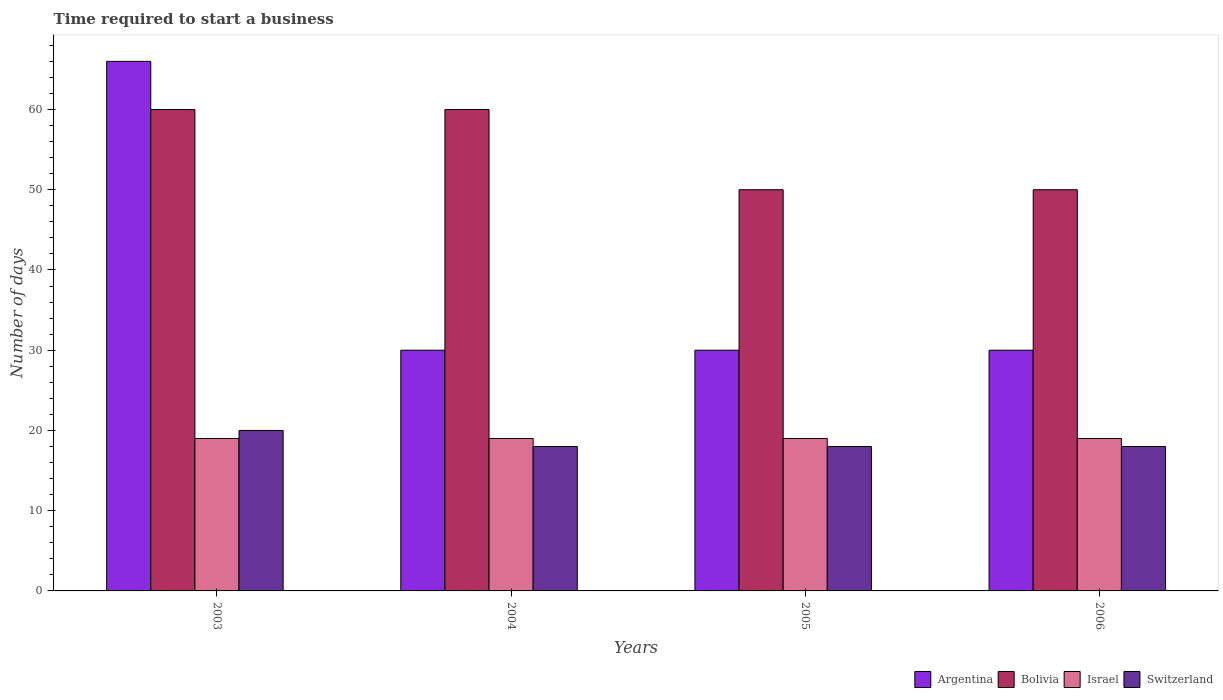How many groups of bars are there?
Offer a very short reply. 4. Are the number of bars per tick equal to the number of legend labels?
Make the answer very short. Yes. What is the label of the 3rd group of bars from the left?
Your answer should be very brief. 2005. Across all years, what is the maximum number of days required to start a business in Switzerland?
Keep it short and to the point. 20. Across all years, what is the minimum number of days required to start a business in Israel?
Your response must be concise. 19. What is the total number of days required to start a business in Argentina in the graph?
Provide a succinct answer. 156. What is the difference between the number of days required to start a business in Bolivia in 2003 and that in 2006?
Ensure brevity in your answer.  10. What is the difference between the number of days required to start a business in Argentina in 2005 and the number of days required to start a business in Israel in 2006?
Ensure brevity in your answer.  11. What is the average number of days required to start a business in Bolivia per year?
Provide a short and direct response. 55. In how many years, is the number of days required to start a business in Israel greater than 46 days?
Make the answer very short. 0. What is the ratio of the number of days required to start a business in Bolivia in 2003 to that in 2005?
Provide a succinct answer. 1.2. Is the difference between the number of days required to start a business in Bolivia in 2003 and 2004 greater than the difference between the number of days required to start a business in Argentina in 2003 and 2004?
Give a very brief answer. No. What is the difference between the highest and the lowest number of days required to start a business in Bolivia?
Your answer should be compact. 10. In how many years, is the number of days required to start a business in Bolivia greater than the average number of days required to start a business in Bolivia taken over all years?
Provide a short and direct response. 2. What does the 1st bar from the left in 2005 represents?
Your answer should be compact. Argentina. What does the 1st bar from the right in 2005 represents?
Offer a terse response. Switzerland. How many bars are there?
Keep it short and to the point. 16. What is the difference between two consecutive major ticks on the Y-axis?
Offer a very short reply. 10. Does the graph contain grids?
Your response must be concise. No. Where does the legend appear in the graph?
Ensure brevity in your answer.  Bottom right. How are the legend labels stacked?
Provide a succinct answer. Horizontal. What is the title of the graph?
Provide a short and direct response. Time required to start a business. What is the label or title of the X-axis?
Your response must be concise. Years. What is the label or title of the Y-axis?
Offer a very short reply. Number of days. What is the Number of days in Argentina in 2004?
Provide a short and direct response. 30. What is the Number of days of Bolivia in 2004?
Keep it short and to the point. 60. What is the Number of days of Israel in 2004?
Your response must be concise. 19. What is the Number of days in Switzerland in 2004?
Your answer should be compact. 18. What is the Number of days of Bolivia in 2005?
Give a very brief answer. 50. What is the Number of days of Switzerland in 2005?
Offer a very short reply. 18. What is the Number of days in Bolivia in 2006?
Offer a terse response. 50. What is the Number of days in Switzerland in 2006?
Offer a terse response. 18. Across all years, what is the maximum Number of days of Bolivia?
Provide a short and direct response. 60. Across all years, what is the maximum Number of days in Israel?
Give a very brief answer. 19. Across all years, what is the maximum Number of days of Switzerland?
Your answer should be very brief. 20. Across all years, what is the minimum Number of days in Bolivia?
Your answer should be very brief. 50. What is the total Number of days of Argentina in the graph?
Give a very brief answer. 156. What is the total Number of days of Bolivia in the graph?
Provide a short and direct response. 220. What is the total Number of days in Israel in the graph?
Your answer should be compact. 76. What is the difference between the Number of days of Argentina in 2003 and that in 2004?
Give a very brief answer. 36. What is the difference between the Number of days of Israel in 2003 and that in 2004?
Offer a terse response. 0. What is the difference between the Number of days in Argentina in 2003 and that in 2005?
Your response must be concise. 36. What is the difference between the Number of days of Bolivia in 2003 and that in 2006?
Provide a succinct answer. 10. What is the difference between the Number of days in Switzerland in 2003 and that in 2006?
Your answer should be very brief. 2. What is the difference between the Number of days in Argentina in 2004 and that in 2005?
Provide a succinct answer. 0. What is the difference between the Number of days in Bolivia in 2004 and that in 2005?
Provide a short and direct response. 10. What is the difference between the Number of days in Israel in 2004 and that in 2005?
Offer a terse response. 0. What is the difference between the Number of days of Switzerland in 2004 and that in 2005?
Make the answer very short. 0. What is the difference between the Number of days of Argentina in 2004 and that in 2006?
Your answer should be very brief. 0. What is the difference between the Number of days in Bolivia in 2004 and that in 2006?
Keep it short and to the point. 10. What is the difference between the Number of days in Argentina in 2005 and that in 2006?
Offer a very short reply. 0. What is the difference between the Number of days of Switzerland in 2005 and that in 2006?
Provide a succinct answer. 0. What is the difference between the Number of days of Bolivia in 2003 and the Number of days of Israel in 2004?
Give a very brief answer. 41. What is the difference between the Number of days of Bolivia in 2003 and the Number of days of Switzerland in 2004?
Make the answer very short. 42. What is the difference between the Number of days in Argentina in 2003 and the Number of days in Bolivia in 2005?
Your answer should be compact. 16. What is the difference between the Number of days in Argentina in 2003 and the Number of days in Switzerland in 2005?
Ensure brevity in your answer.  48. What is the difference between the Number of days in Bolivia in 2003 and the Number of days in Israel in 2005?
Keep it short and to the point. 41. What is the difference between the Number of days in Israel in 2003 and the Number of days in Switzerland in 2005?
Your answer should be compact. 1. What is the difference between the Number of days of Argentina in 2003 and the Number of days of Israel in 2006?
Keep it short and to the point. 47. What is the difference between the Number of days in Argentina in 2003 and the Number of days in Switzerland in 2006?
Make the answer very short. 48. What is the difference between the Number of days of Israel in 2003 and the Number of days of Switzerland in 2006?
Your answer should be compact. 1. What is the difference between the Number of days of Argentina in 2004 and the Number of days of Israel in 2005?
Provide a short and direct response. 11. What is the difference between the Number of days in Argentina in 2004 and the Number of days in Switzerland in 2005?
Your answer should be compact. 12. What is the difference between the Number of days of Bolivia in 2004 and the Number of days of Israel in 2005?
Provide a short and direct response. 41. What is the difference between the Number of days of Israel in 2004 and the Number of days of Switzerland in 2005?
Provide a short and direct response. 1. What is the difference between the Number of days of Argentina in 2004 and the Number of days of Israel in 2006?
Ensure brevity in your answer.  11. What is the difference between the Number of days in Argentina in 2004 and the Number of days in Switzerland in 2006?
Your answer should be compact. 12. What is the difference between the Number of days of Bolivia in 2004 and the Number of days of Israel in 2006?
Offer a terse response. 41. What is the difference between the Number of days in Argentina in 2005 and the Number of days in Switzerland in 2006?
Provide a short and direct response. 12. What is the difference between the Number of days in Bolivia in 2005 and the Number of days in Switzerland in 2006?
Offer a terse response. 32. What is the difference between the Number of days of Israel in 2005 and the Number of days of Switzerland in 2006?
Ensure brevity in your answer.  1. What is the average Number of days in Israel per year?
Provide a succinct answer. 19. What is the average Number of days in Switzerland per year?
Provide a short and direct response. 18.5. In the year 2003, what is the difference between the Number of days in Argentina and Number of days in Israel?
Ensure brevity in your answer.  47. In the year 2003, what is the difference between the Number of days of Argentina and Number of days of Switzerland?
Your response must be concise. 46. In the year 2003, what is the difference between the Number of days in Bolivia and Number of days in Israel?
Your response must be concise. 41. In the year 2003, what is the difference between the Number of days in Israel and Number of days in Switzerland?
Your response must be concise. -1. In the year 2004, what is the difference between the Number of days in Argentina and Number of days in Israel?
Keep it short and to the point. 11. In the year 2004, what is the difference between the Number of days in Argentina and Number of days in Switzerland?
Provide a short and direct response. 12. In the year 2005, what is the difference between the Number of days of Argentina and Number of days of Bolivia?
Give a very brief answer. -20. In the year 2005, what is the difference between the Number of days in Argentina and Number of days in Israel?
Keep it short and to the point. 11. In the year 2005, what is the difference between the Number of days in Argentina and Number of days in Switzerland?
Provide a succinct answer. 12. In the year 2005, what is the difference between the Number of days in Bolivia and Number of days in Israel?
Provide a short and direct response. 31. In the year 2005, what is the difference between the Number of days in Bolivia and Number of days in Switzerland?
Provide a succinct answer. 32. In the year 2006, what is the difference between the Number of days of Argentina and Number of days of Israel?
Provide a short and direct response. 11. In the year 2006, what is the difference between the Number of days of Bolivia and Number of days of Switzerland?
Offer a terse response. 32. What is the ratio of the Number of days in Argentina in 2003 to that in 2004?
Your response must be concise. 2.2. What is the ratio of the Number of days of Bolivia in 2003 to that in 2005?
Provide a succinct answer. 1.2. What is the ratio of the Number of days of Israel in 2003 to that in 2005?
Make the answer very short. 1. What is the ratio of the Number of days in Switzerland in 2003 to that in 2005?
Give a very brief answer. 1.11. What is the ratio of the Number of days in Israel in 2004 to that in 2006?
Your answer should be compact. 1. What is the ratio of the Number of days of Argentina in 2005 to that in 2006?
Provide a short and direct response. 1. What is the ratio of the Number of days of Bolivia in 2005 to that in 2006?
Your answer should be very brief. 1. What is the ratio of the Number of days in Israel in 2005 to that in 2006?
Give a very brief answer. 1. What is the ratio of the Number of days in Switzerland in 2005 to that in 2006?
Offer a very short reply. 1. What is the difference between the highest and the second highest Number of days in Bolivia?
Ensure brevity in your answer.  0. What is the difference between the highest and the second highest Number of days in Switzerland?
Ensure brevity in your answer.  2. What is the difference between the highest and the lowest Number of days in Argentina?
Make the answer very short. 36. What is the difference between the highest and the lowest Number of days of Bolivia?
Keep it short and to the point. 10. 